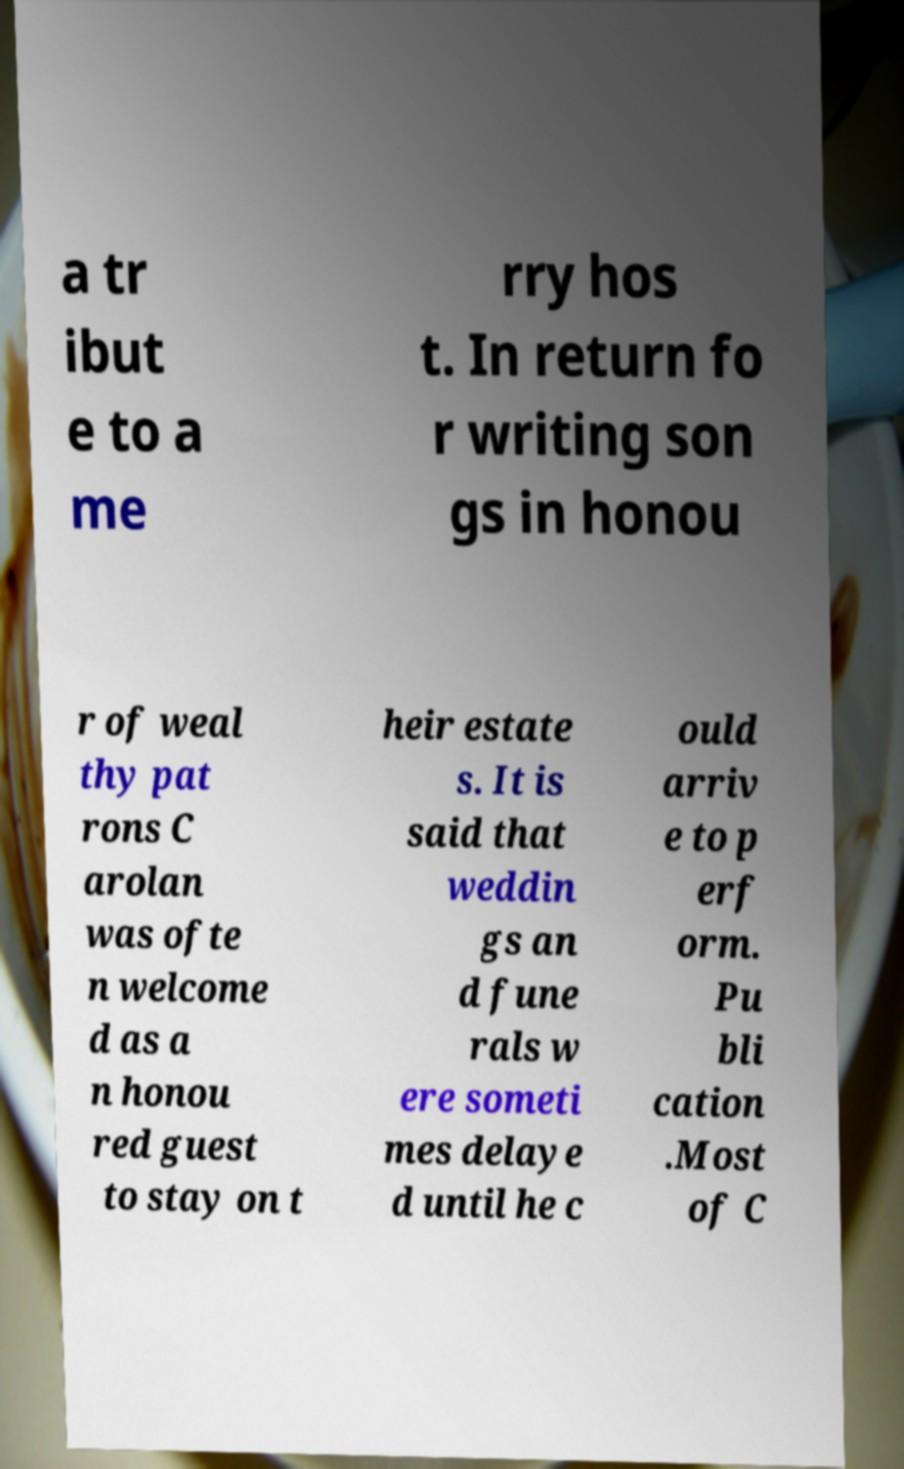Could you extract and type out the text from this image? a tr ibut e to a me rry hos t. In return fo r writing son gs in honou r of weal thy pat rons C arolan was ofte n welcome d as a n honou red guest to stay on t heir estate s. It is said that weddin gs an d fune rals w ere someti mes delaye d until he c ould arriv e to p erf orm. Pu bli cation .Most of C 